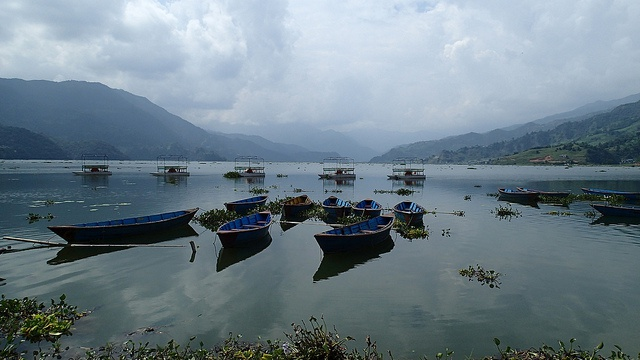Describe the objects in this image and their specific colors. I can see boat in lightblue, gray, black, darkgray, and blue tones, boat in lightblue, black, navy, and gray tones, boat in lightblue, black, navy, and gray tones, boat in lightblue, black, navy, gray, and darkgray tones, and boat in lightblue, black, darkgray, gray, and navy tones in this image. 